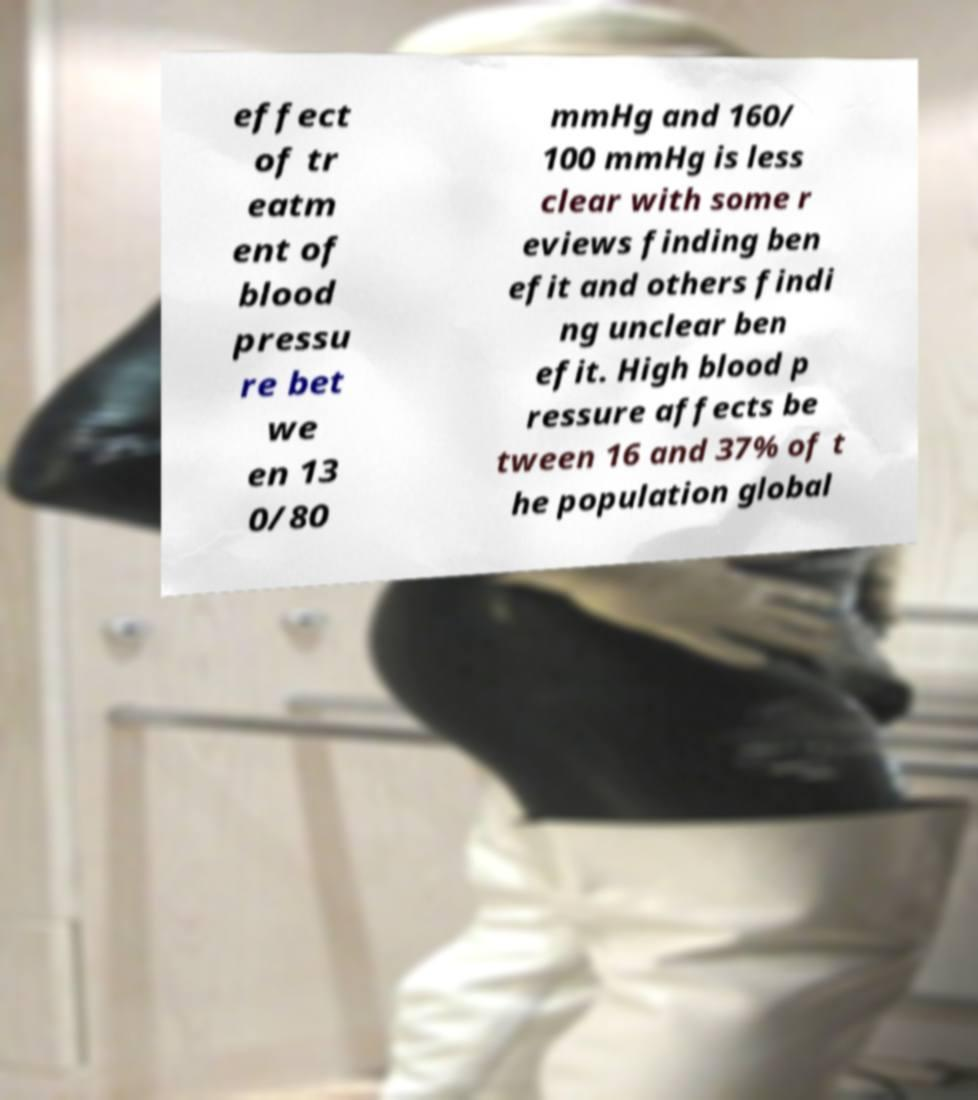Can you accurately transcribe the text from the provided image for me? effect of tr eatm ent of blood pressu re bet we en 13 0/80 mmHg and 160/ 100 mmHg is less clear with some r eviews finding ben efit and others findi ng unclear ben efit. High blood p ressure affects be tween 16 and 37% of t he population global 